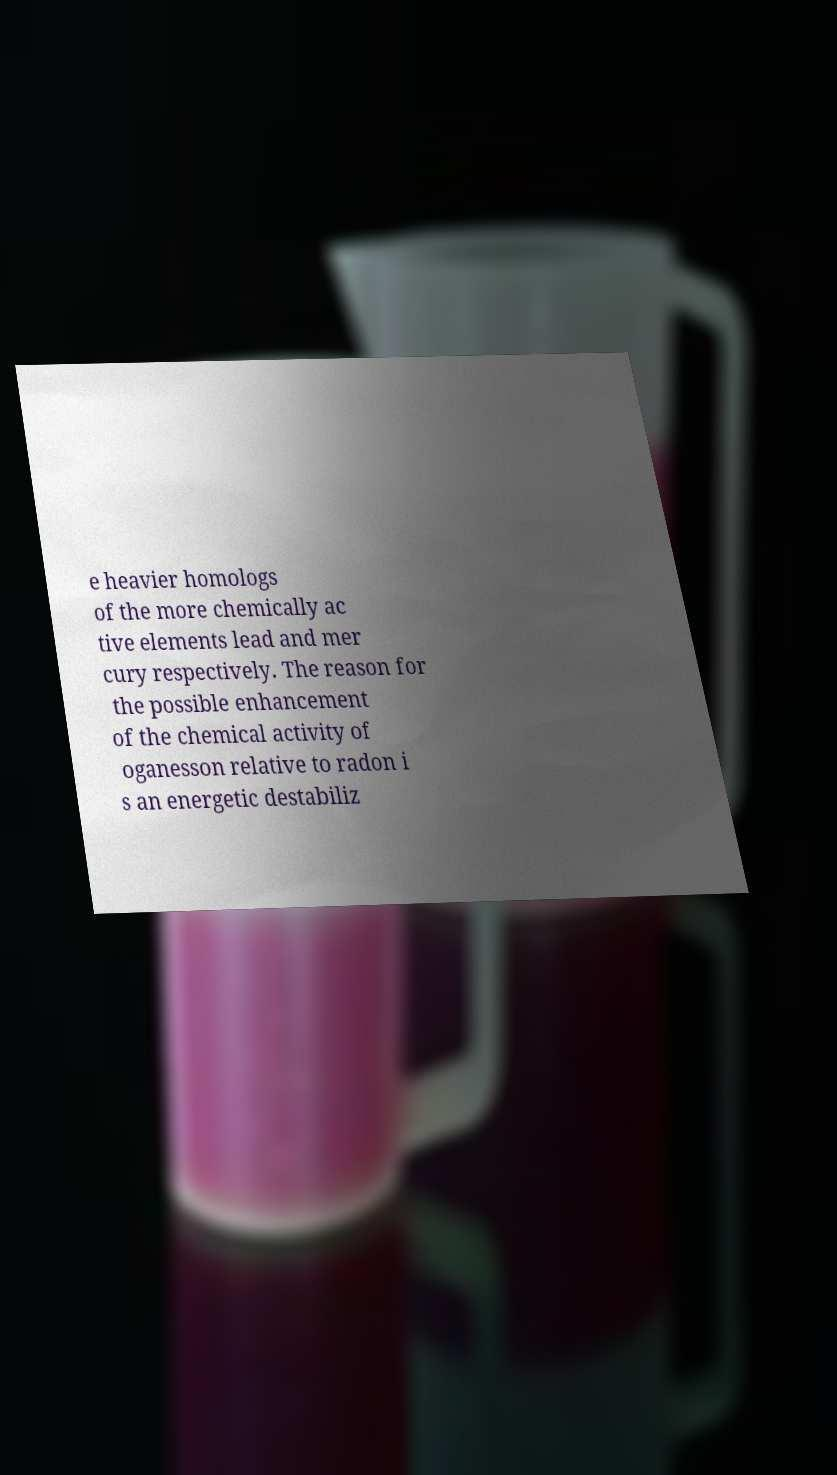Please identify and transcribe the text found in this image. e heavier homologs of the more chemically ac tive elements lead and mer cury respectively. The reason for the possible enhancement of the chemical activity of oganesson relative to radon i s an energetic destabiliz 